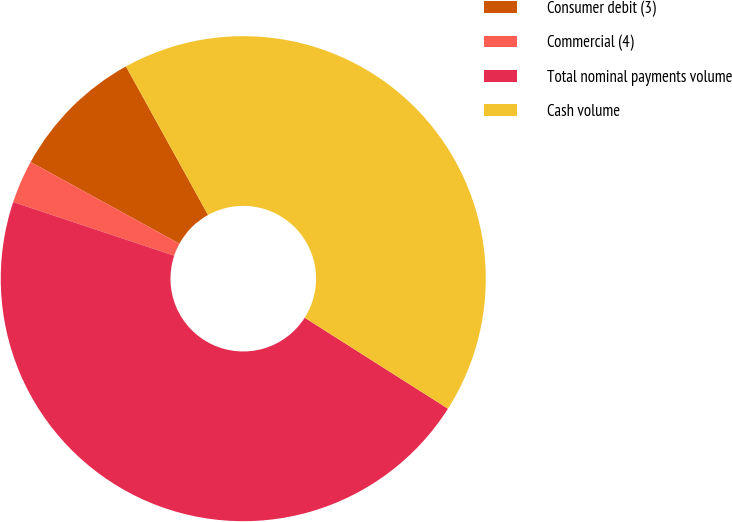<chart> <loc_0><loc_0><loc_500><loc_500><pie_chart><fcel>Consumer debit (3)<fcel>Commercial (4)<fcel>Total nominal payments volume<fcel>Cash volume<nl><fcel>8.98%<fcel>2.87%<fcel>46.11%<fcel>42.04%<nl></chart> 